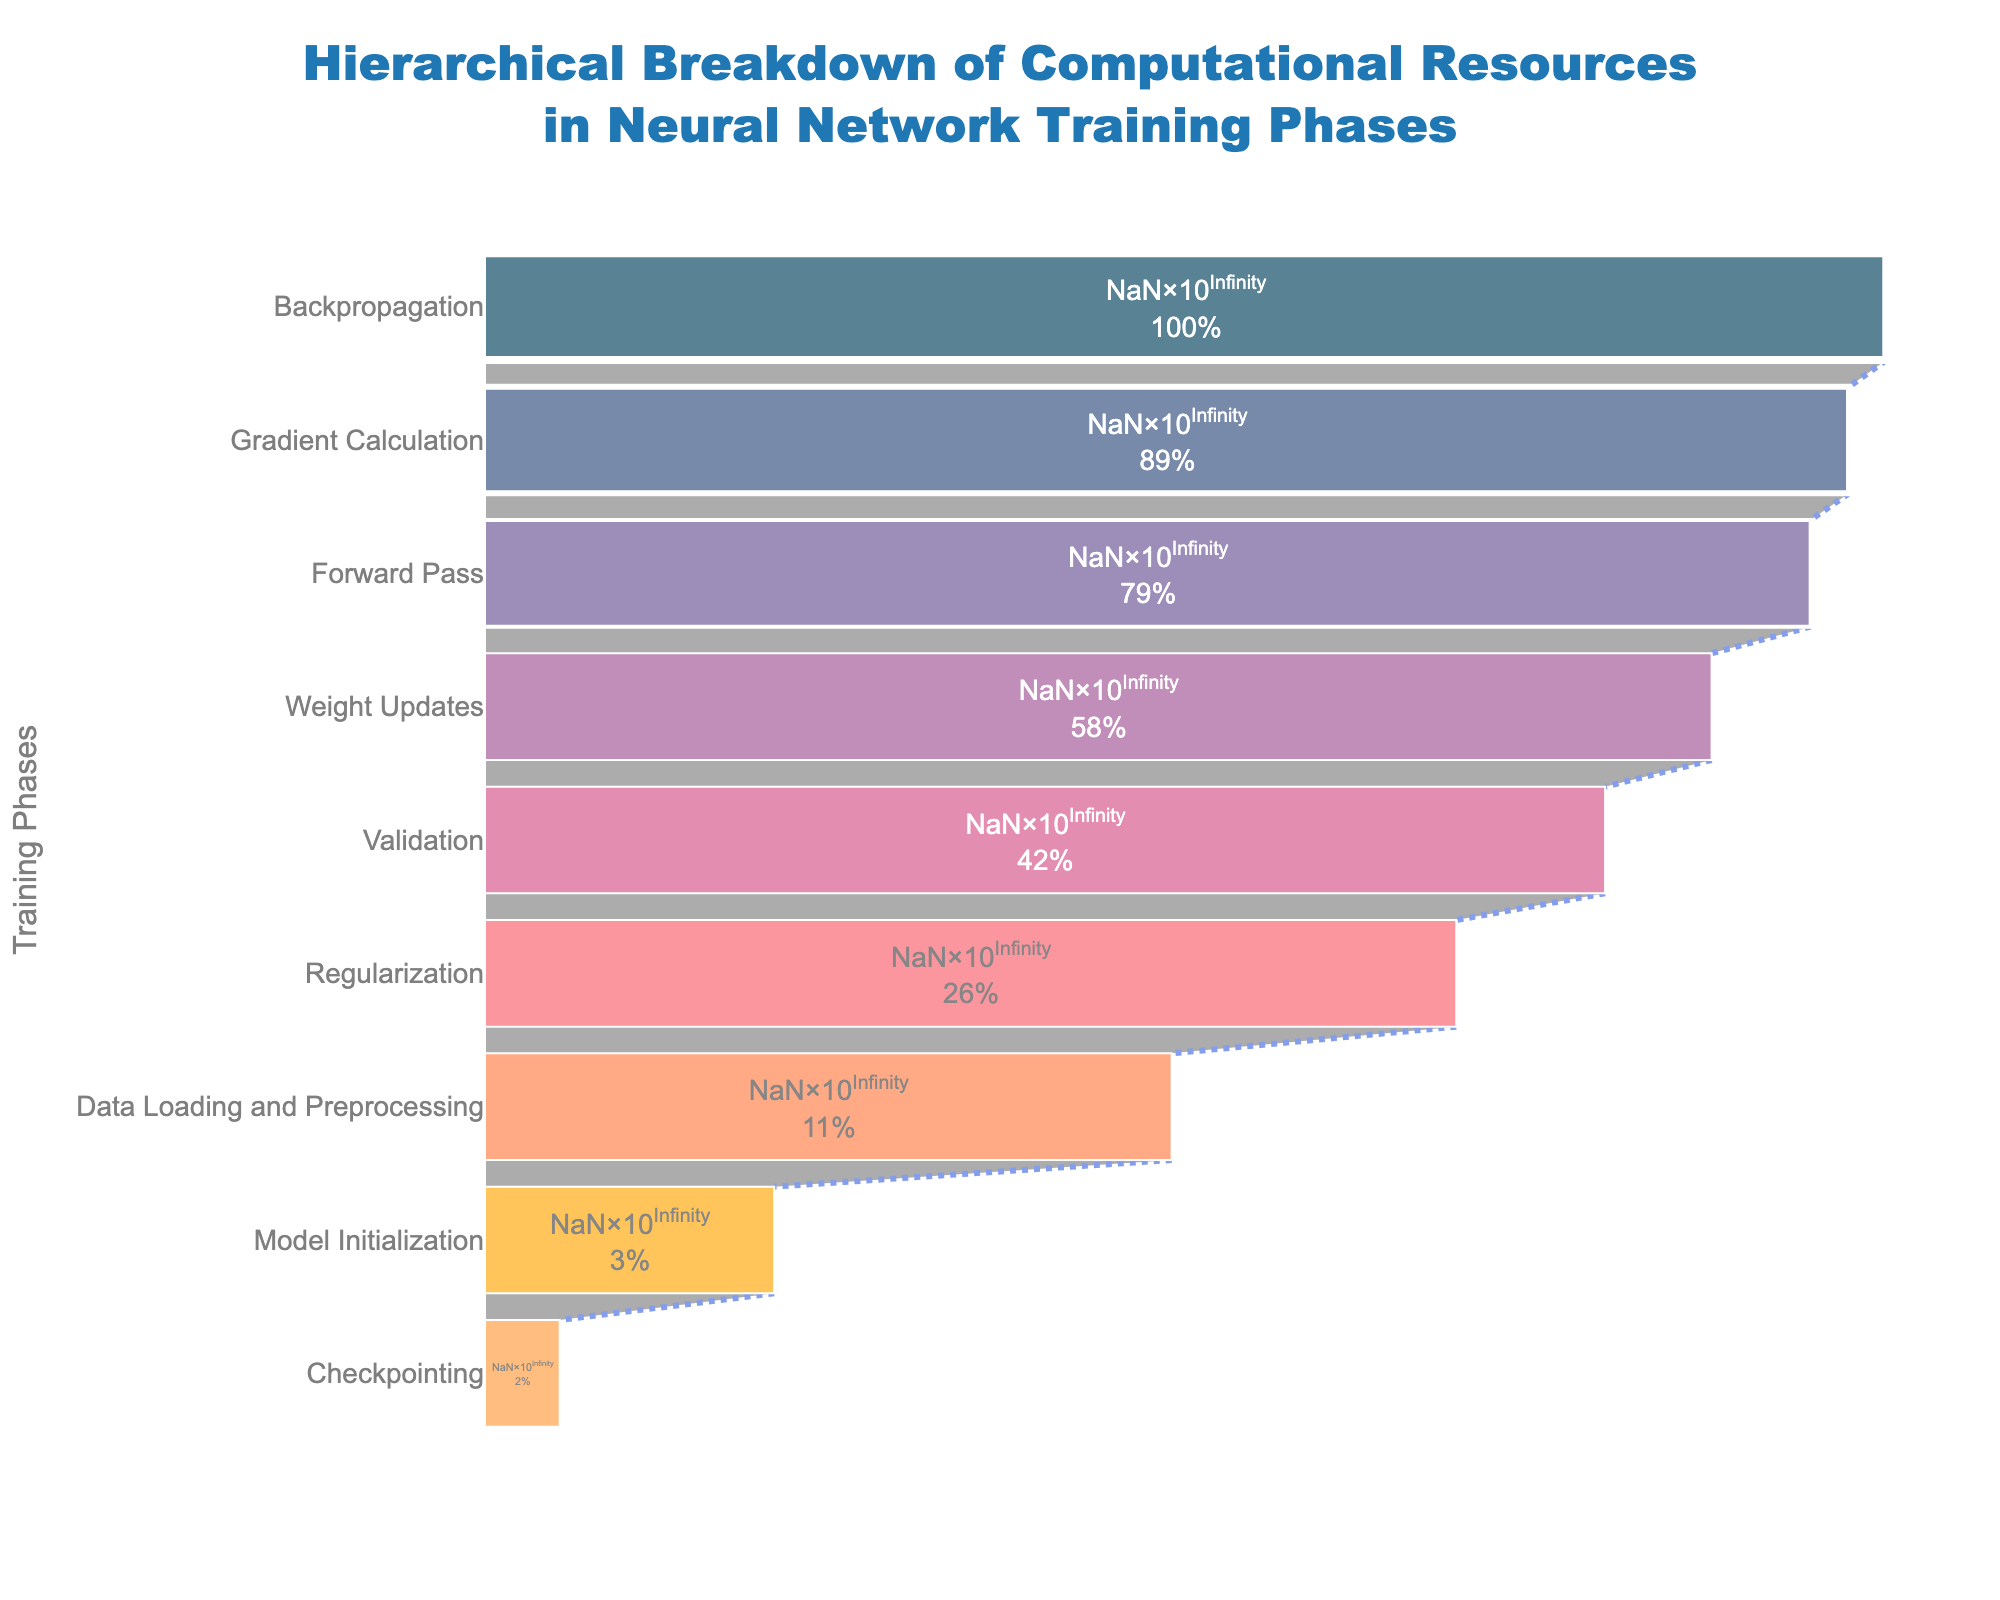What's the title of the funnel chart? The title is located at the top of the chart in a larger font size and in a bold style. The title provides a summary of what the chart is about, namely the hierarchical breakdown of computational resources in neural network training phases.
Answer: Hierarchical Breakdown of Computational Resources in Neural Network Training Phases Which phase consumes the most computational resources? The funnel chart arranges the phases in descending order of computational resources. The top-most phase in the chart has the highest value.
Answer: Backpropagation How many phases are depicted in the funnel chart? Count the number of distinct phases listed along the y-axis from top to bottom. Each represents a phase in the training process.
Answer: 9 What percentage of the initial resources is consumed by the Weight Updates phase? Look at the Weight Updates phase bar and refer to the percentage provided inside the funnel chart. This value represents the percentage of total initial resources consumed by this phase.
Answer: 20.50% Compare the computational resources consumed by the Gradient Calculation and Regularization phases. Which is higher and by how much? Find the respective bars for Gradient Calculation and Regularization in the funnel chart. The length of each bar represents the computational resources. Subtract the resources for Regularization from those for Gradient Calculation to find the difference.
Answer: Gradient Calculation by 6.9e12 - 2.9e12 = 7.0e12 FLOPS What are the total computational resources consumed by the Forward Pass and Data Loading and Preprocessing phases? Identify the bars for Forward Pass and Data Loading and Preprocessing, and sum their individual computational resources.
Answer: 8.7e12 + 1.2e12 = 9.9e12 FLOPS Which phase is sandwiched between two phases with lower computational resources? Examine the funnel chart to find a phase whose bar is between two bars that are shorter in length, indicating lower computational resources.
Answer: Validation (between Regularization and Data Loading and Preprocessing) By what multiple are the resources used in Checkpointing less than those used in Forward Pass? Divide the computational resources used in the Forward Pass by those used in Checkpointing to find the relative multiple.
Answer: 8.7e12 / 1.8e11 = 48.33 times What is the difference in computational resources between the Data Loading and Preprocessing phase and Model Initialization phase? Identify the bars and their corresponding resources for these two phases in the chart. Subtract the resources of the Model Initialization phase from those of the Data Loading and Preprocessing phase.
Answer: 1.2e12 - 3.5e11 = 8.5e11 FLOPS 